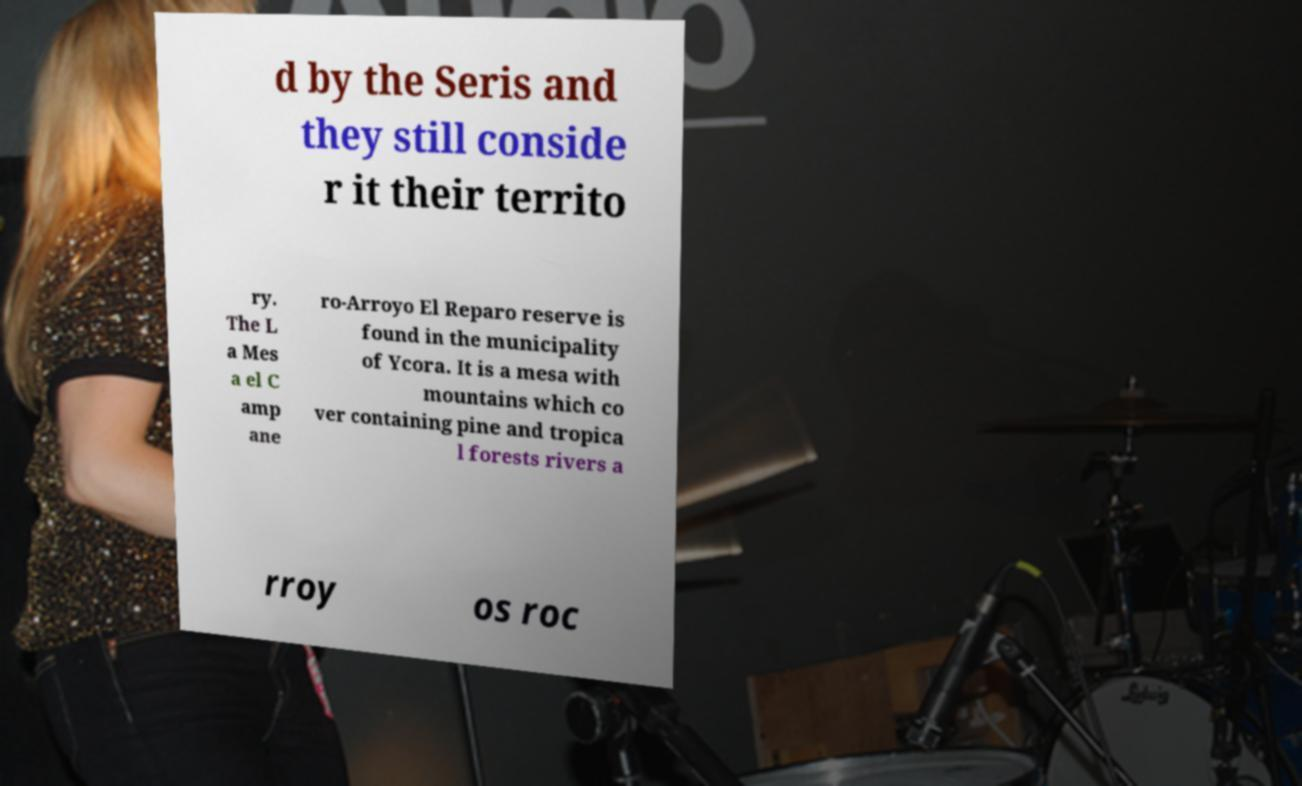What messages or text are displayed in this image? I need them in a readable, typed format. d by the Seris and they still conside r it their territo ry. The L a Mes a el C amp ane ro-Arroyo El Reparo reserve is found in the municipality of Ycora. It is a mesa with mountains which co ver containing pine and tropica l forests rivers a rroy os roc 